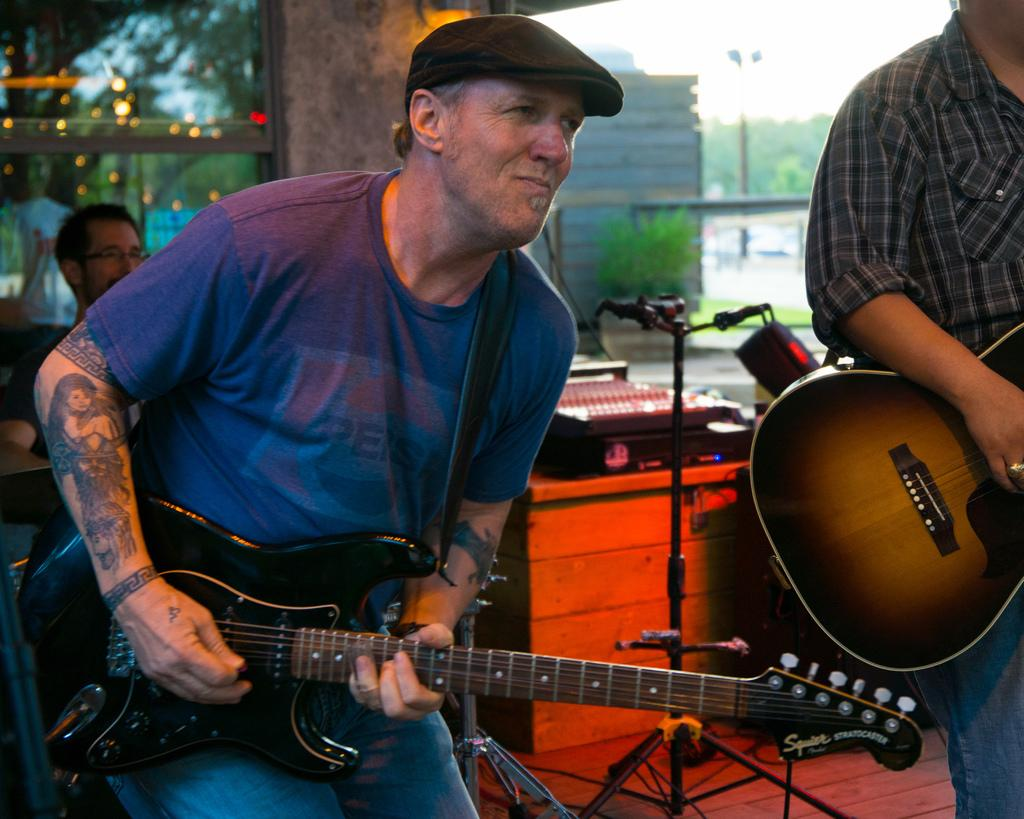What is the person in the image holding? The person is holding a guitar. What else can be seen in the image besides the person and the guitar? There is a pole and a plant visible in the image. What is visible in the background of the image? The sky is visible in the image. What type of wax is being used to create the guitar in the image? There is no indication in the image that wax is being used to create the guitar. How many tickets are visible in the image? There are no tickets present in the image. 